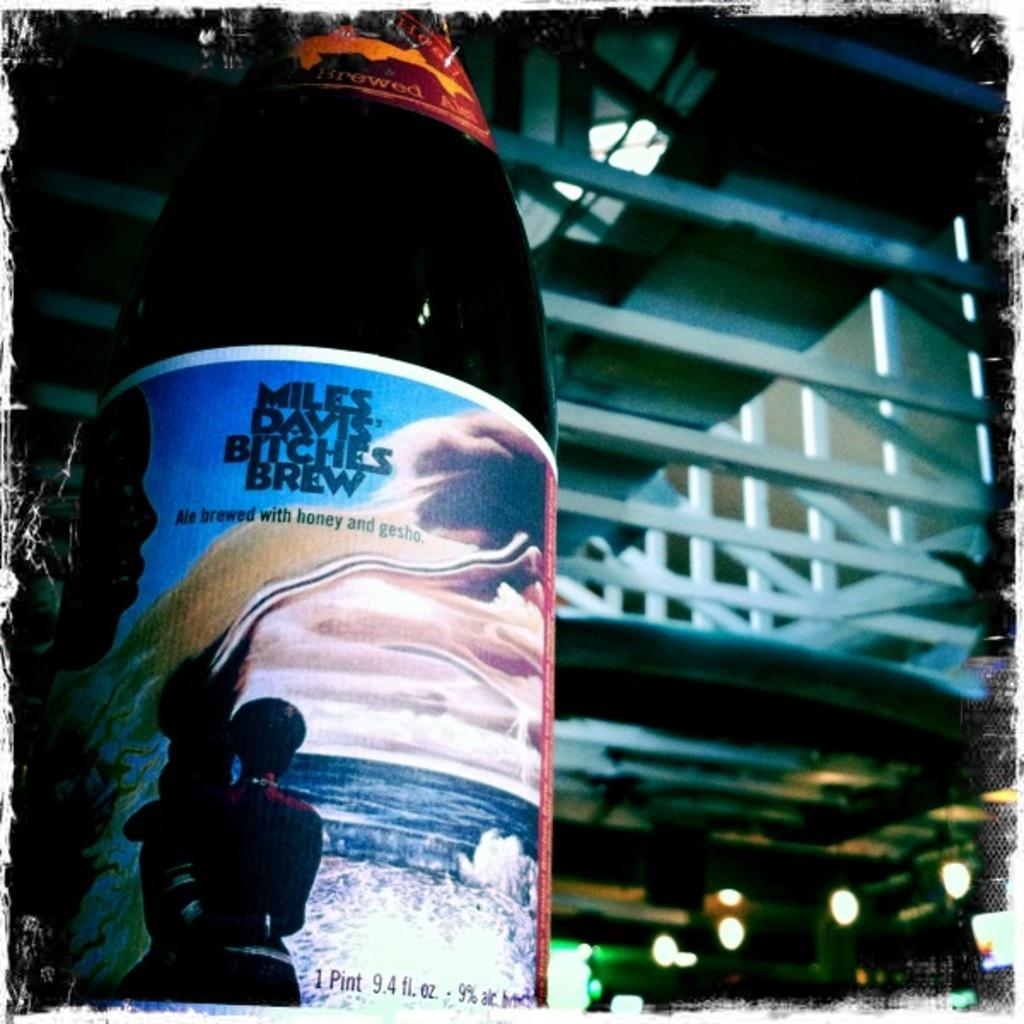<image>
Share a concise interpretation of the image provided. A bottle of Miles Davies Brew sits against a dark alleyway 